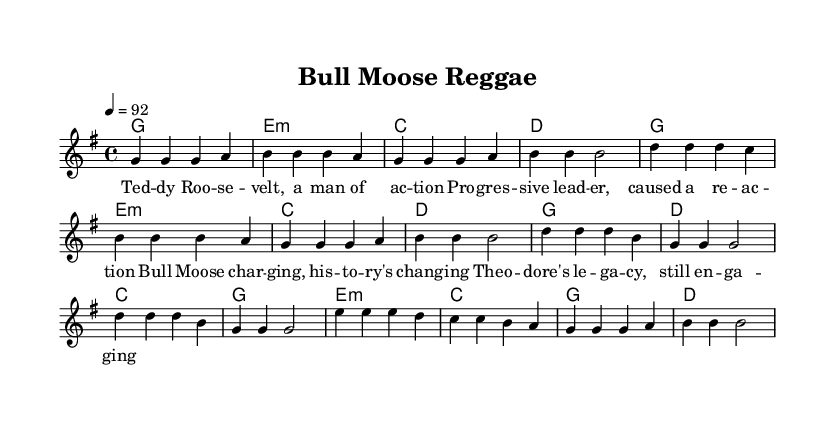What is the key signature of this music? The key signature is identified by the presence of one sharp (F#) in the context of G major. This indicates that the music is played in G major, which is evident from the initial indication of \key g \major.
Answer: G major What is the time signature of this music? The time signature is represented by the format \time 4/4, meaning there are four beats in each measure and a quarter note gets one beat. This can be confirmed by the consistent grouping of four notes in each measure throughout the piece.
Answer: 4/4 What is the tempo of this music? The tempo is indicated as 4 = 92, which means that there are 92 beats per minute at a quarter note. This information is provided right after the time signature in the global settings of the code.
Answer: 92 How many measures are there in the verse? The verse consists of a series of musical phrases, which can be counted based on the written sections. There are a total of 8 measures in the verse section, identified by the grouping of bars.
Answer: 8 What chord follows the first line of the verse? The first line of the verse starts with the melody g g g a and is accompanied by the chord g1, as indicated in the harmonies below the melody. Therefore, the chord that follows is G major.
Answer: G major What is the lyrical theme of the song? The lyrics focus on Theodore Roosevelt and his impact, as conveyed through phrases like "man of action" and "progressive leader." This indicates a theme celebrating strong historical leadership and positive change in society.
Answer: Historical leadership What type of song structure is utilized in this music? The music features a common verse-chorus structure, which is typical in reggae songs. The verse provides the context and story, while the chorus encapsulates the central theme, contrasting the two sections.
Answer: Verse-chorus 